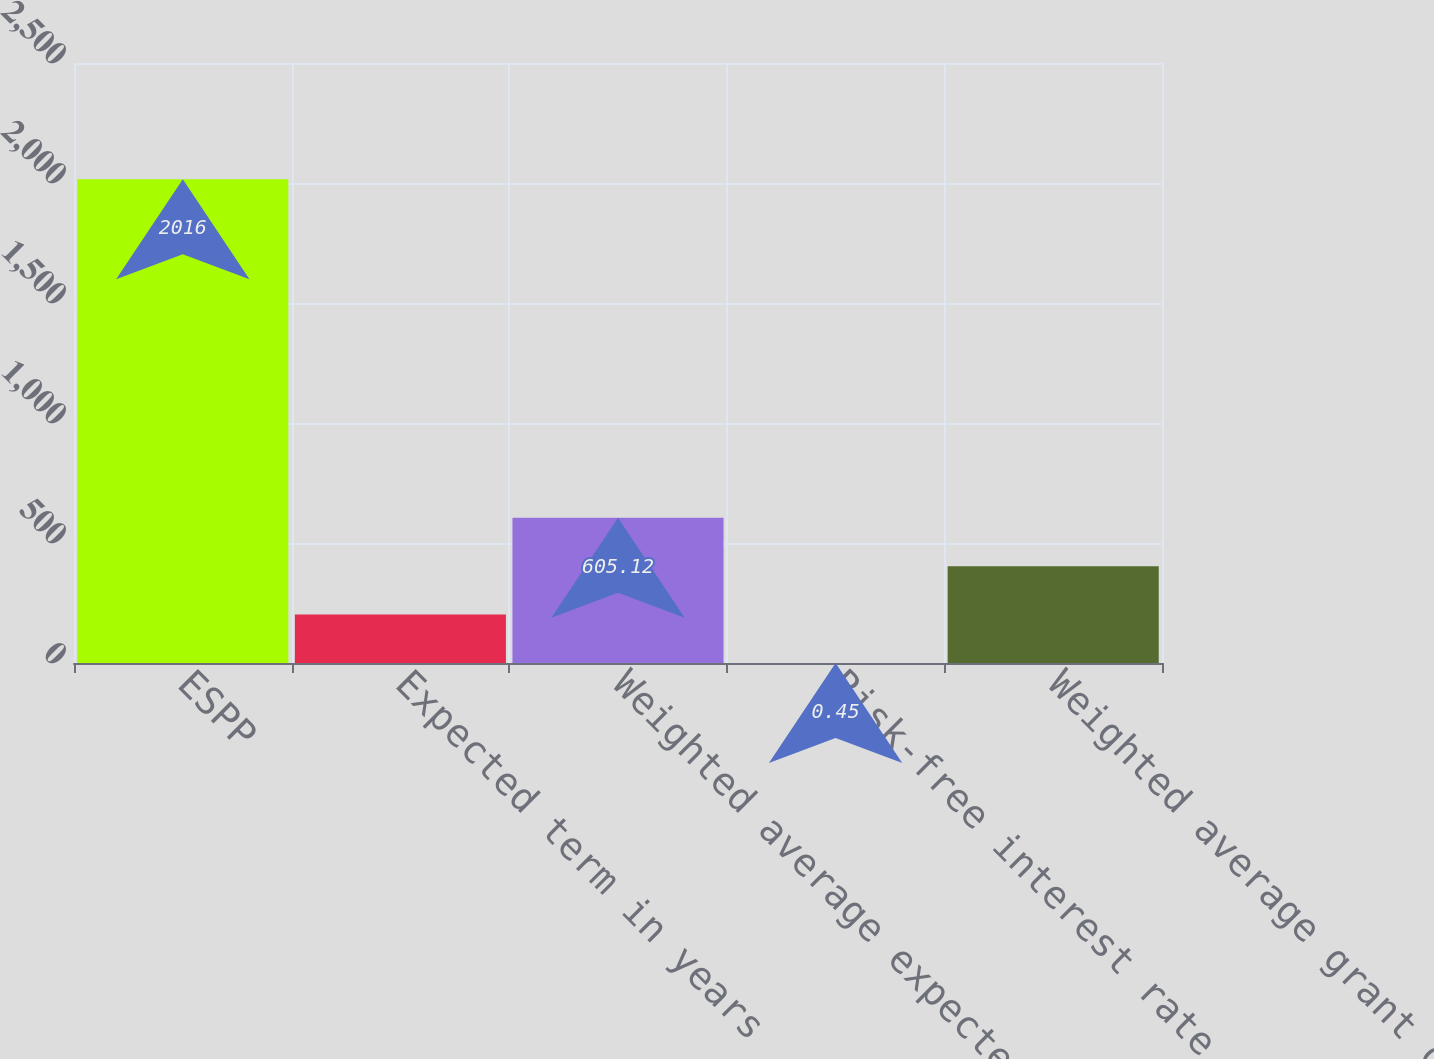<chart> <loc_0><loc_0><loc_500><loc_500><bar_chart><fcel>ESPP<fcel>Expected term in years<fcel>Weighted average expected<fcel>Risk-free interest rate<fcel>Weighted average grant date<nl><fcel>2016<fcel>202<fcel>605.12<fcel>0.45<fcel>403.56<nl></chart> 